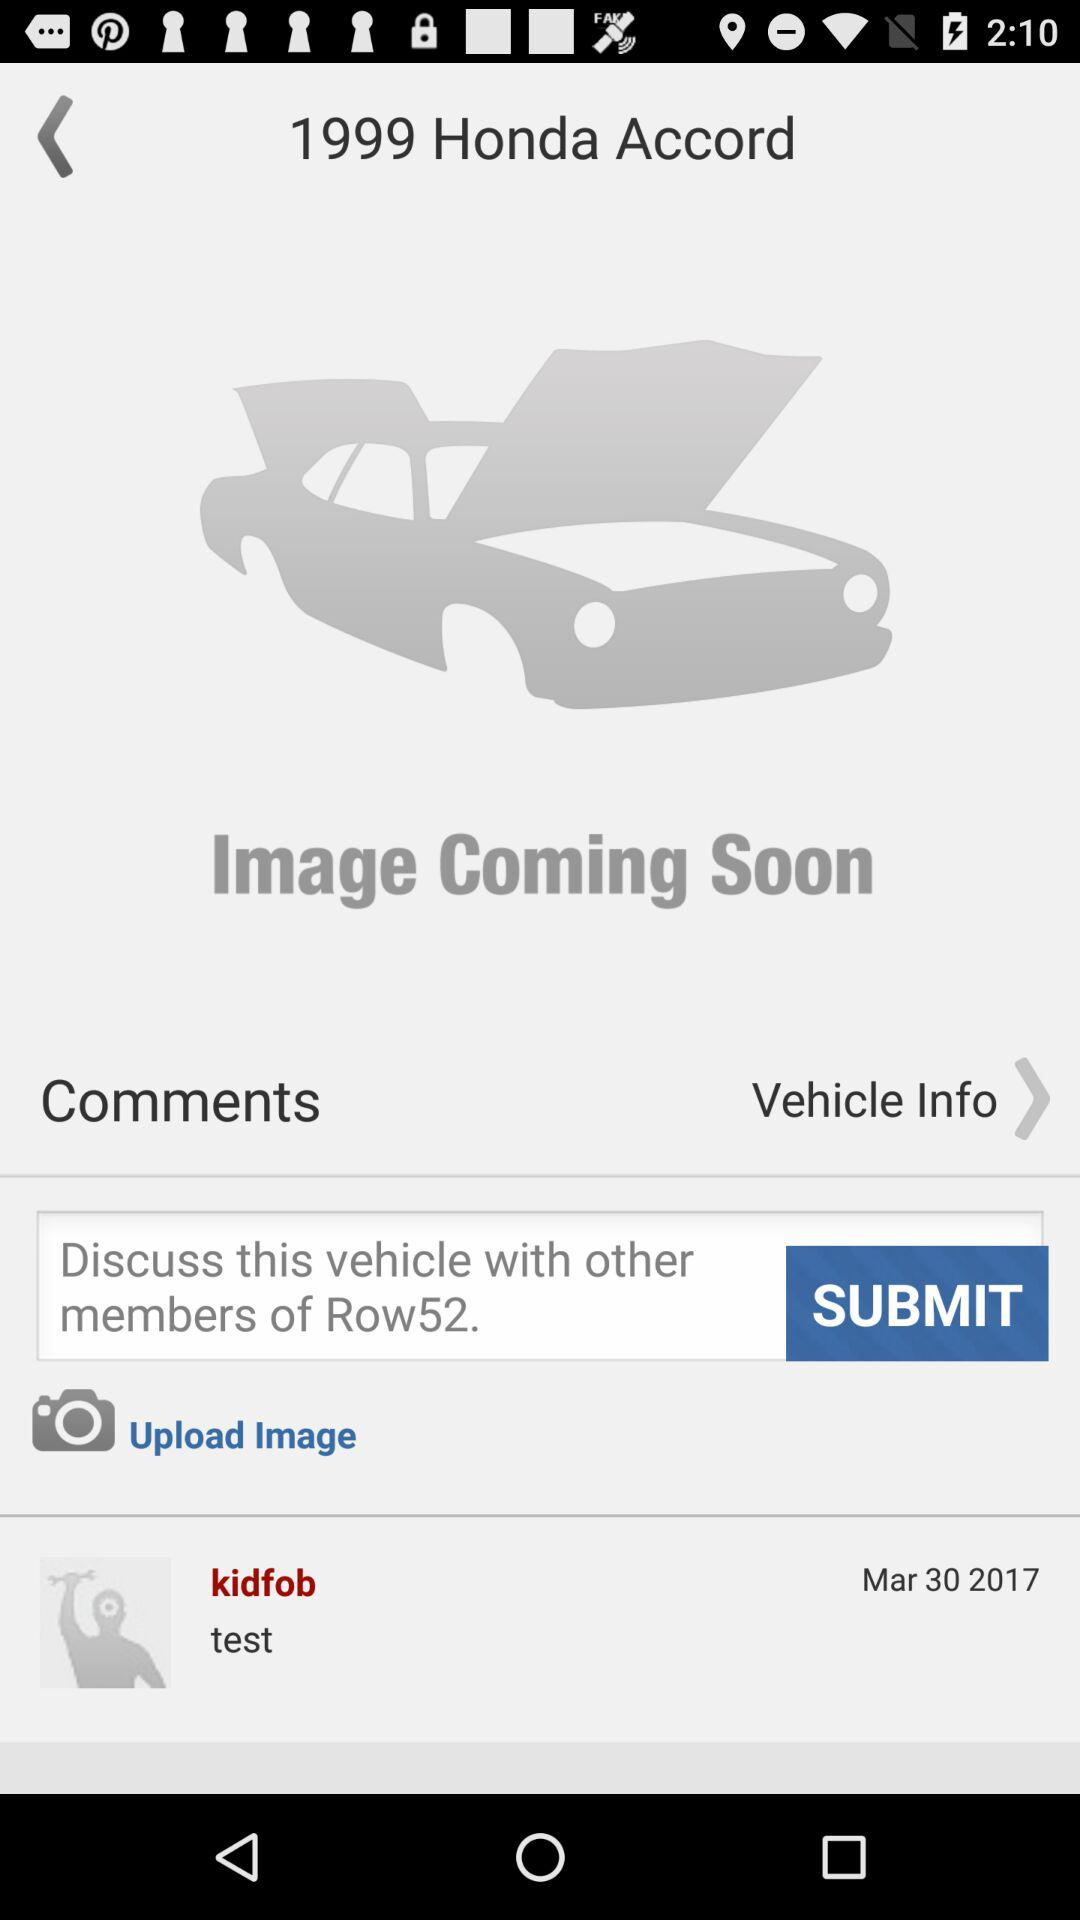What is the date of the "kidfob" test? The date of the "kidfob" test is March 30, 2017. 